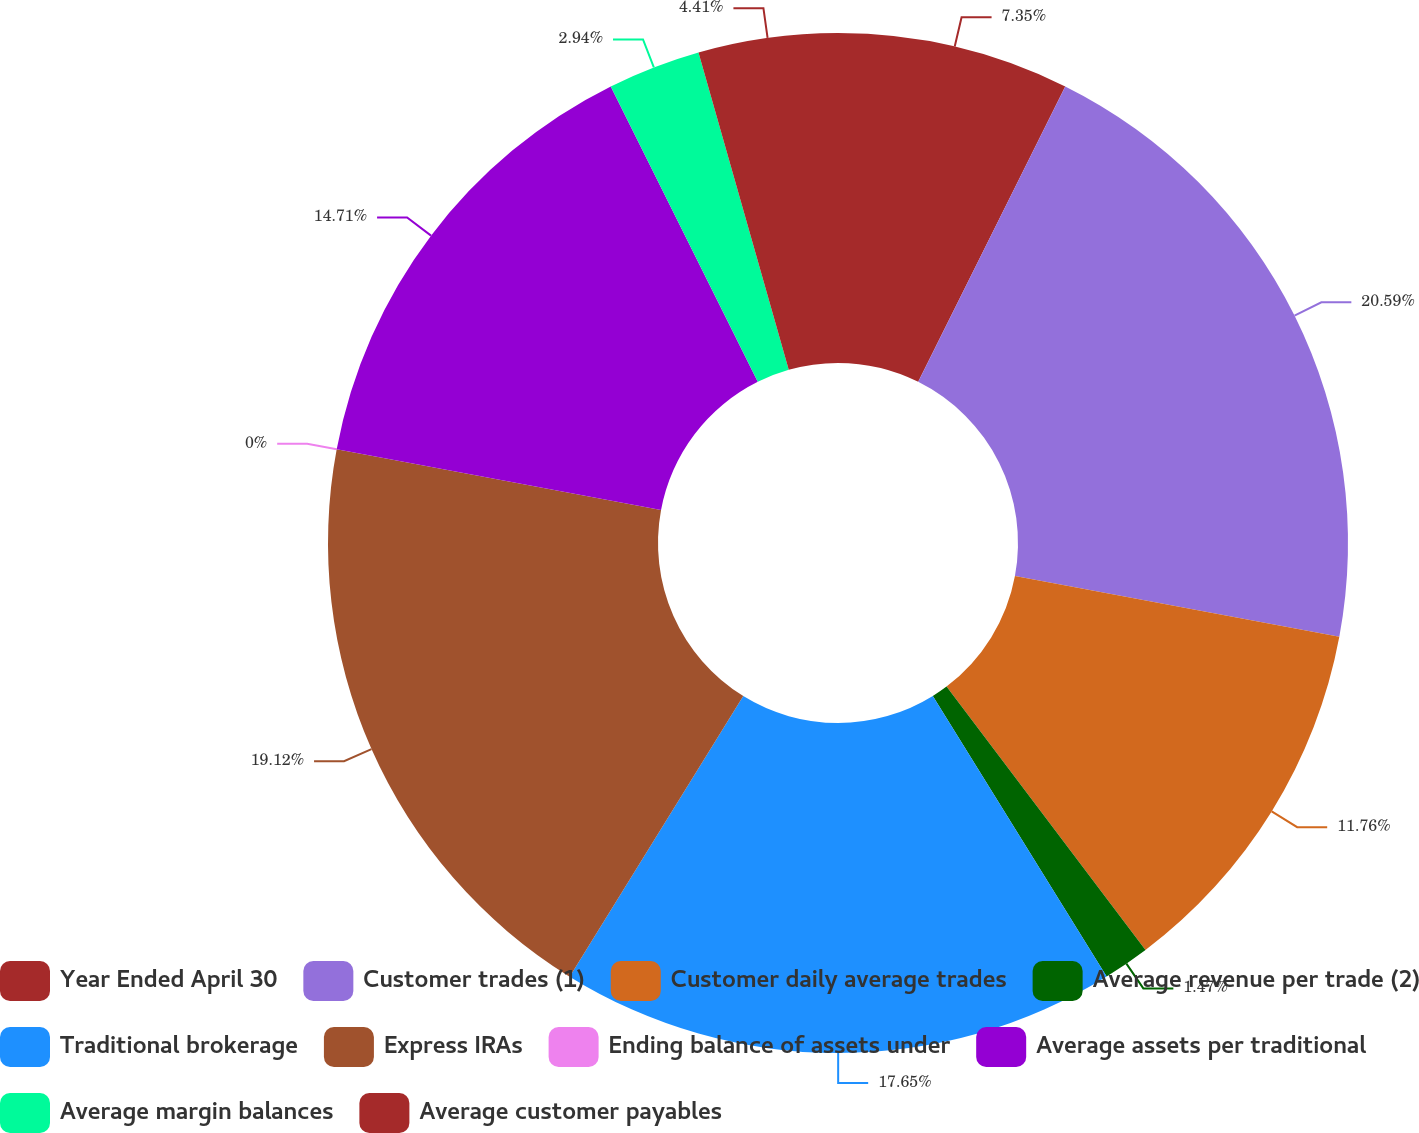Convert chart to OTSL. <chart><loc_0><loc_0><loc_500><loc_500><pie_chart><fcel>Year Ended April 30<fcel>Customer trades (1)<fcel>Customer daily average trades<fcel>Average revenue per trade (2)<fcel>Traditional brokerage<fcel>Express IRAs<fcel>Ending balance of assets under<fcel>Average assets per traditional<fcel>Average margin balances<fcel>Average customer payables<nl><fcel>7.35%<fcel>20.59%<fcel>11.76%<fcel>1.47%<fcel>17.65%<fcel>19.12%<fcel>0.0%<fcel>14.71%<fcel>2.94%<fcel>4.41%<nl></chart> 